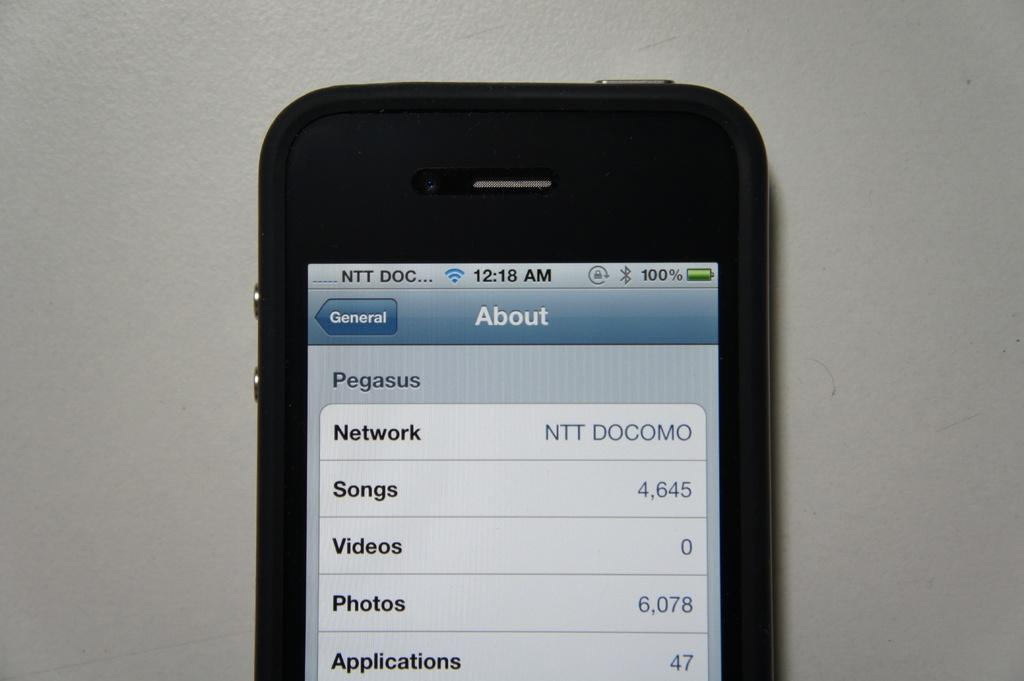<image>
Write a terse but informative summary of the picture. A cell phone face up with the word about on the top of the screen 